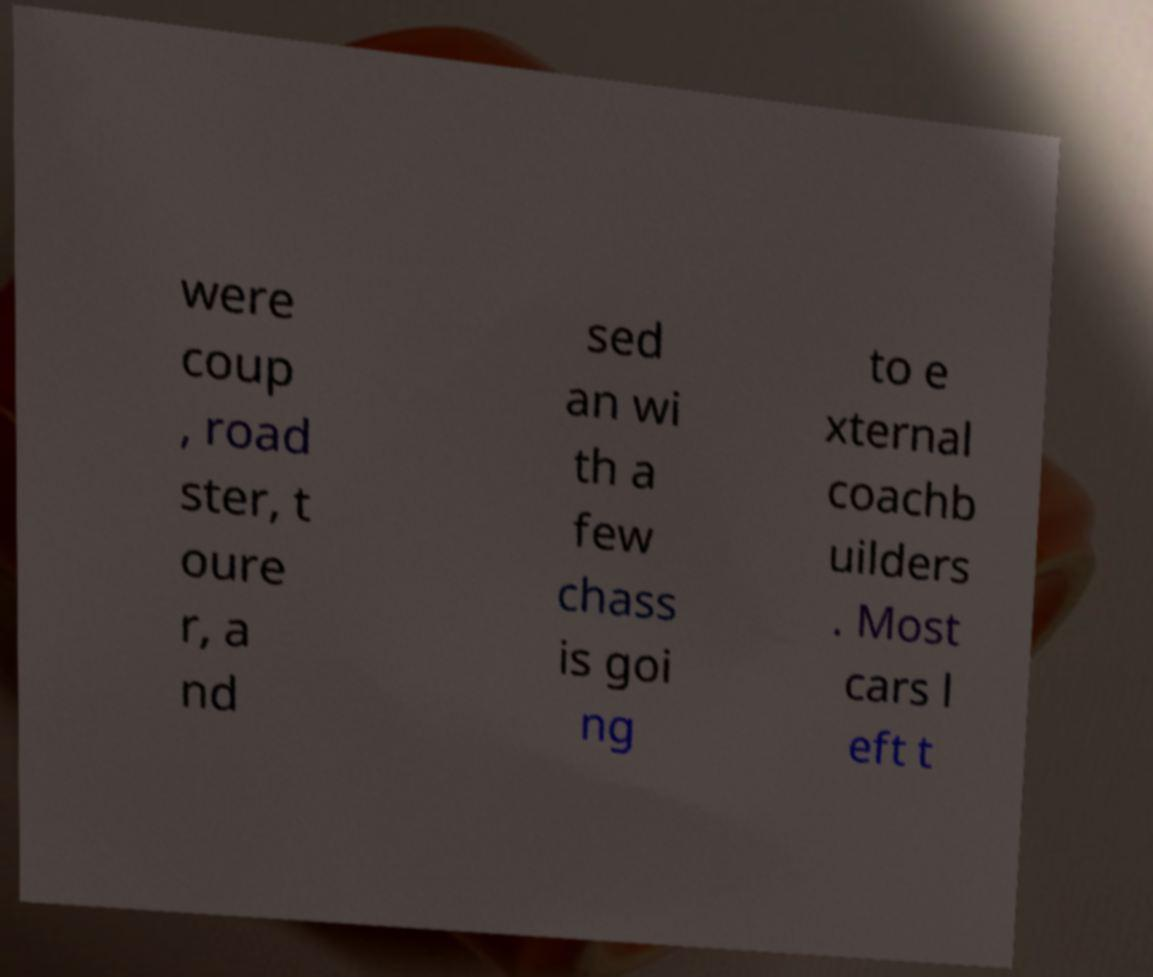Please identify and transcribe the text found in this image. were coup , road ster, t oure r, a nd sed an wi th a few chass is goi ng to e xternal coachb uilders . Most cars l eft t 